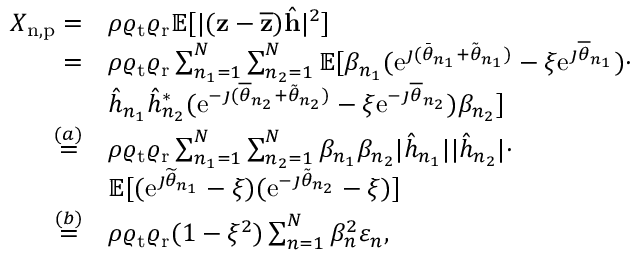<formula> <loc_0><loc_0><loc_500><loc_500>\begin{array} { r l } { X _ { n , p } = } & { \rho \varrho _ { t } \varrho _ { r } \mathbb { E } [ | ( z - \overline { z } ) \hat { h } | ^ { 2 } ] } \\ { = } & { \rho \varrho _ { t } \varrho _ { r } \sum _ { n _ { 1 } = 1 } ^ { N } \sum _ { n _ { 2 } = 1 } ^ { N } \mathbb { E } [ \beta _ { n _ { 1 } } ( e ^ { \jmath ( \bar { \theta } _ { n _ { 1 } } + \tilde { \theta } _ { n _ { 1 } } ) } - \xi e ^ { \jmath \overline { \theta } _ { n _ { 1 } } } ) \cdot } \\ & { \hat { h } _ { n _ { 1 } } \hat { h } _ { n _ { 2 } } ^ { * } ( e ^ { - \jmath ( \overline { \theta } _ { n _ { 2 } } + \tilde { \theta } _ { n _ { 2 } } ) } - \xi e ^ { - \jmath \overline { \theta } _ { n _ { 2 } } } ) \beta _ { n _ { 2 } } ] } \\ { \overset { ( a ) } { = } } & { \rho \varrho _ { t } \varrho _ { r } \sum _ { n _ { 1 } = 1 } ^ { N } \sum _ { n _ { 2 } = 1 } ^ { N } \beta _ { n _ { 1 } } \beta _ { n _ { 2 } } | \hat { h } _ { n _ { 1 } } | | \hat { h } _ { n _ { 2 } } | \cdot } \\ & { \mathbb { E } [ ( e ^ { \jmath \widetilde { \theta } _ { n _ { 1 } } } - \xi ) ( e ^ { - \jmath \tilde { \theta } _ { n _ { 2 } } } - \xi ) ] } \\ { \overset { ( b ) } { = } } & { \rho \varrho _ { t } \varrho _ { r } ( 1 - \xi ^ { 2 } ) \sum _ { n = 1 } ^ { N } \beta _ { n } ^ { 2 } \varepsilon _ { n } , } \end{array}</formula> 